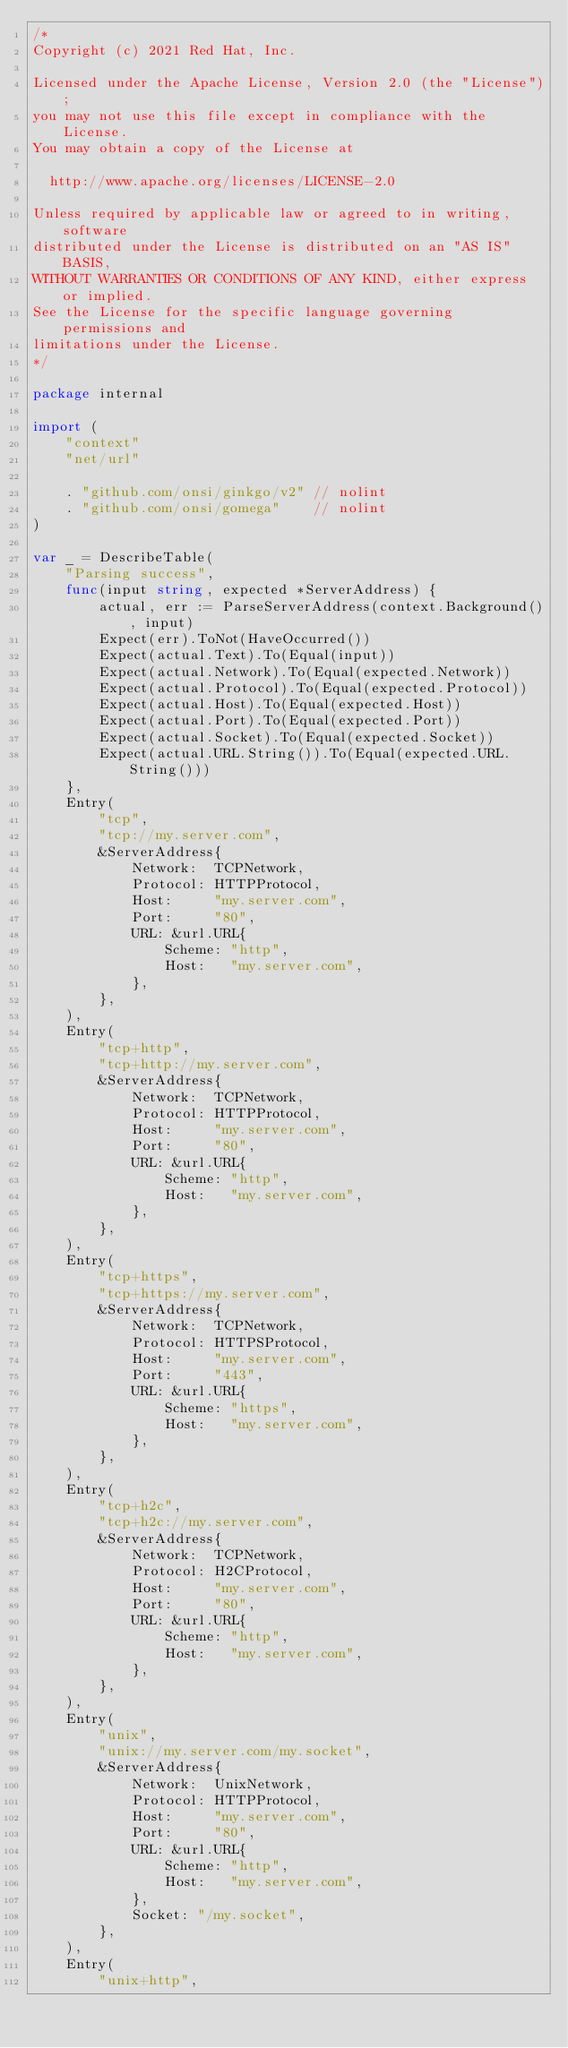<code> <loc_0><loc_0><loc_500><loc_500><_Go_>/*
Copyright (c) 2021 Red Hat, Inc.

Licensed under the Apache License, Version 2.0 (the "License");
you may not use this file except in compliance with the License.
You may obtain a copy of the License at

  http://www.apache.org/licenses/LICENSE-2.0

Unless required by applicable law or agreed to in writing, software
distributed under the License is distributed on an "AS IS" BASIS,
WITHOUT WARRANTIES OR CONDITIONS OF ANY KIND, either express or implied.
See the License for the specific language governing permissions and
limitations under the License.
*/

package internal

import (
	"context"
	"net/url"

	. "github.com/onsi/ginkgo/v2" // nolint
	. "github.com/onsi/gomega"    // nolint
)

var _ = DescribeTable(
	"Parsing success",
	func(input string, expected *ServerAddress) {
		actual, err := ParseServerAddress(context.Background(), input)
		Expect(err).ToNot(HaveOccurred())
		Expect(actual.Text).To(Equal(input))
		Expect(actual.Network).To(Equal(expected.Network))
		Expect(actual.Protocol).To(Equal(expected.Protocol))
		Expect(actual.Host).To(Equal(expected.Host))
		Expect(actual.Port).To(Equal(expected.Port))
		Expect(actual.Socket).To(Equal(expected.Socket))
		Expect(actual.URL.String()).To(Equal(expected.URL.String()))
	},
	Entry(
		"tcp",
		"tcp://my.server.com",
		&ServerAddress{
			Network:  TCPNetwork,
			Protocol: HTTPProtocol,
			Host:     "my.server.com",
			Port:     "80",
			URL: &url.URL{
				Scheme: "http",
				Host:   "my.server.com",
			},
		},
	),
	Entry(
		"tcp+http",
		"tcp+http://my.server.com",
		&ServerAddress{
			Network:  TCPNetwork,
			Protocol: HTTPProtocol,
			Host:     "my.server.com",
			Port:     "80",
			URL: &url.URL{
				Scheme: "http",
				Host:   "my.server.com",
			},
		},
	),
	Entry(
		"tcp+https",
		"tcp+https://my.server.com",
		&ServerAddress{
			Network:  TCPNetwork,
			Protocol: HTTPSProtocol,
			Host:     "my.server.com",
			Port:     "443",
			URL: &url.URL{
				Scheme: "https",
				Host:   "my.server.com",
			},
		},
	),
	Entry(
		"tcp+h2c",
		"tcp+h2c://my.server.com",
		&ServerAddress{
			Network:  TCPNetwork,
			Protocol: H2CProtocol,
			Host:     "my.server.com",
			Port:     "80",
			URL: &url.URL{
				Scheme: "http",
				Host:   "my.server.com",
			},
		},
	),
	Entry(
		"unix",
		"unix://my.server.com/my.socket",
		&ServerAddress{
			Network:  UnixNetwork,
			Protocol: HTTPProtocol,
			Host:     "my.server.com",
			Port:     "80",
			URL: &url.URL{
				Scheme: "http",
				Host:   "my.server.com",
			},
			Socket: "/my.socket",
		},
	),
	Entry(
		"unix+http",</code> 